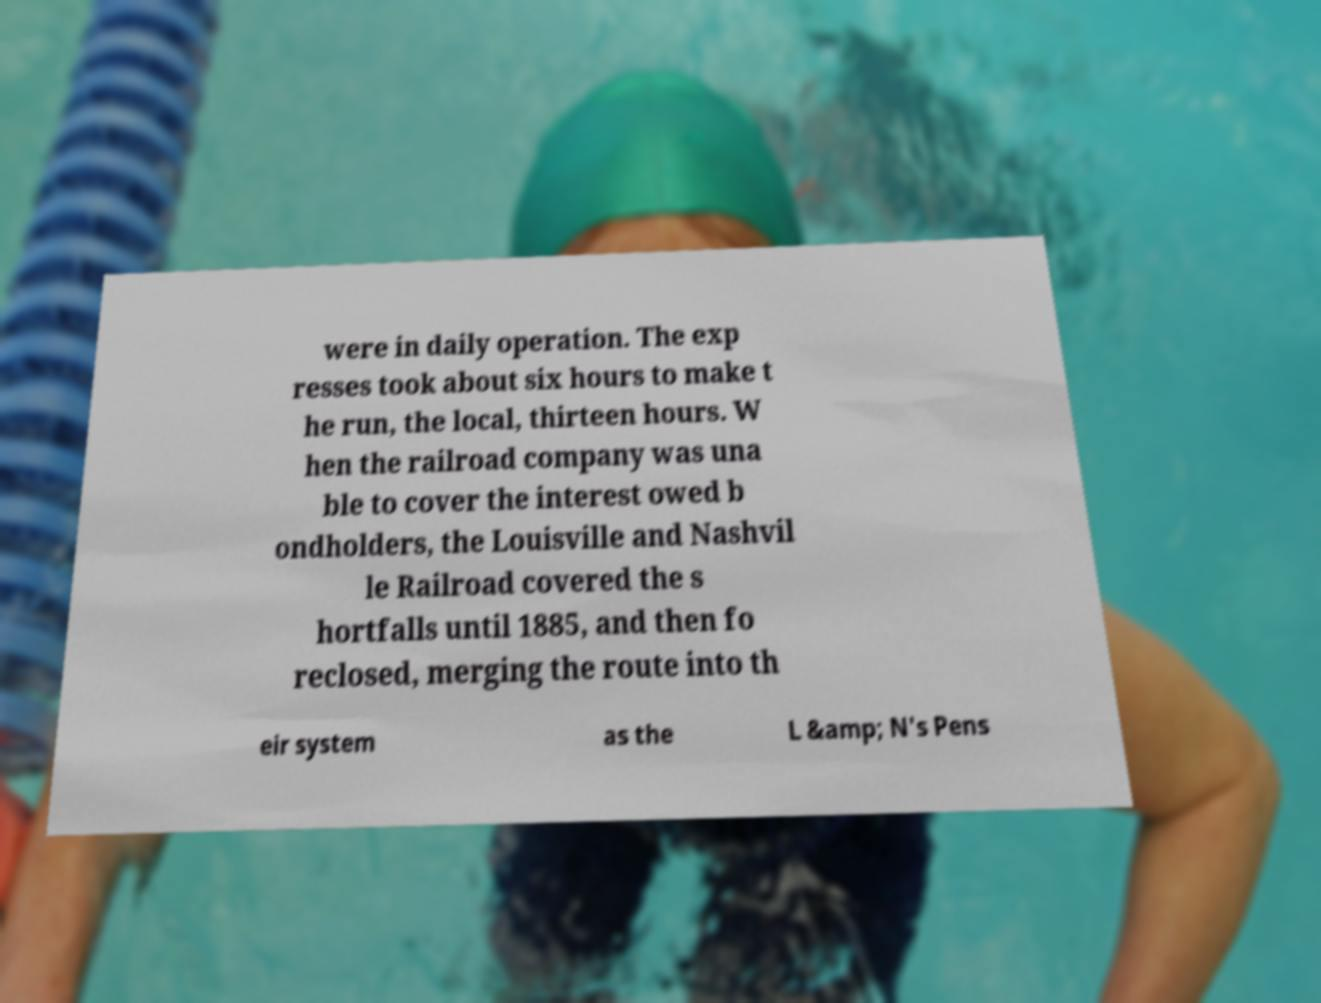Can you accurately transcribe the text from the provided image for me? were in daily operation. The exp resses took about six hours to make t he run, the local, thirteen hours. W hen the railroad company was una ble to cover the interest owed b ondholders, the Louisville and Nashvil le Railroad covered the s hortfalls until 1885, and then fo reclosed, merging the route into th eir system as the L &amp; N's Pens 